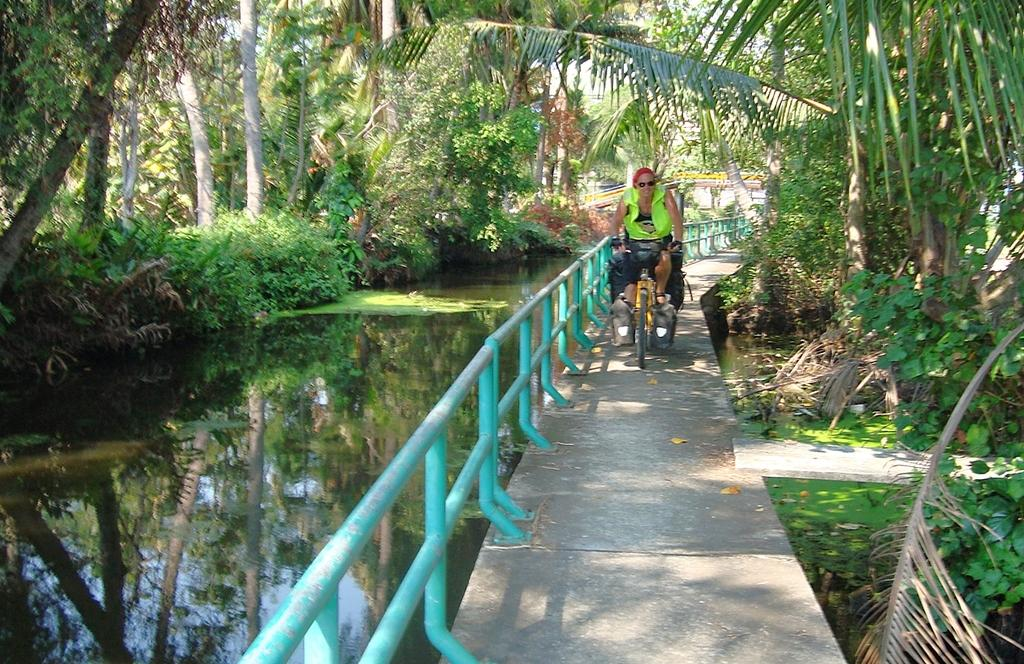What is the main subject of the image? There is a person in the image. What is the person doing in the image? The person is riding a bicycle. Where is the bicycle located? The bicycle is on a bridge. What can be seen in the background of the image? There is a pond surrounded by trees in the image. What is the title of the book the person is reading while riding the bicycle? There is no book or reading activity mentioned in the image; the person is riding a bicycle on a bridge. 